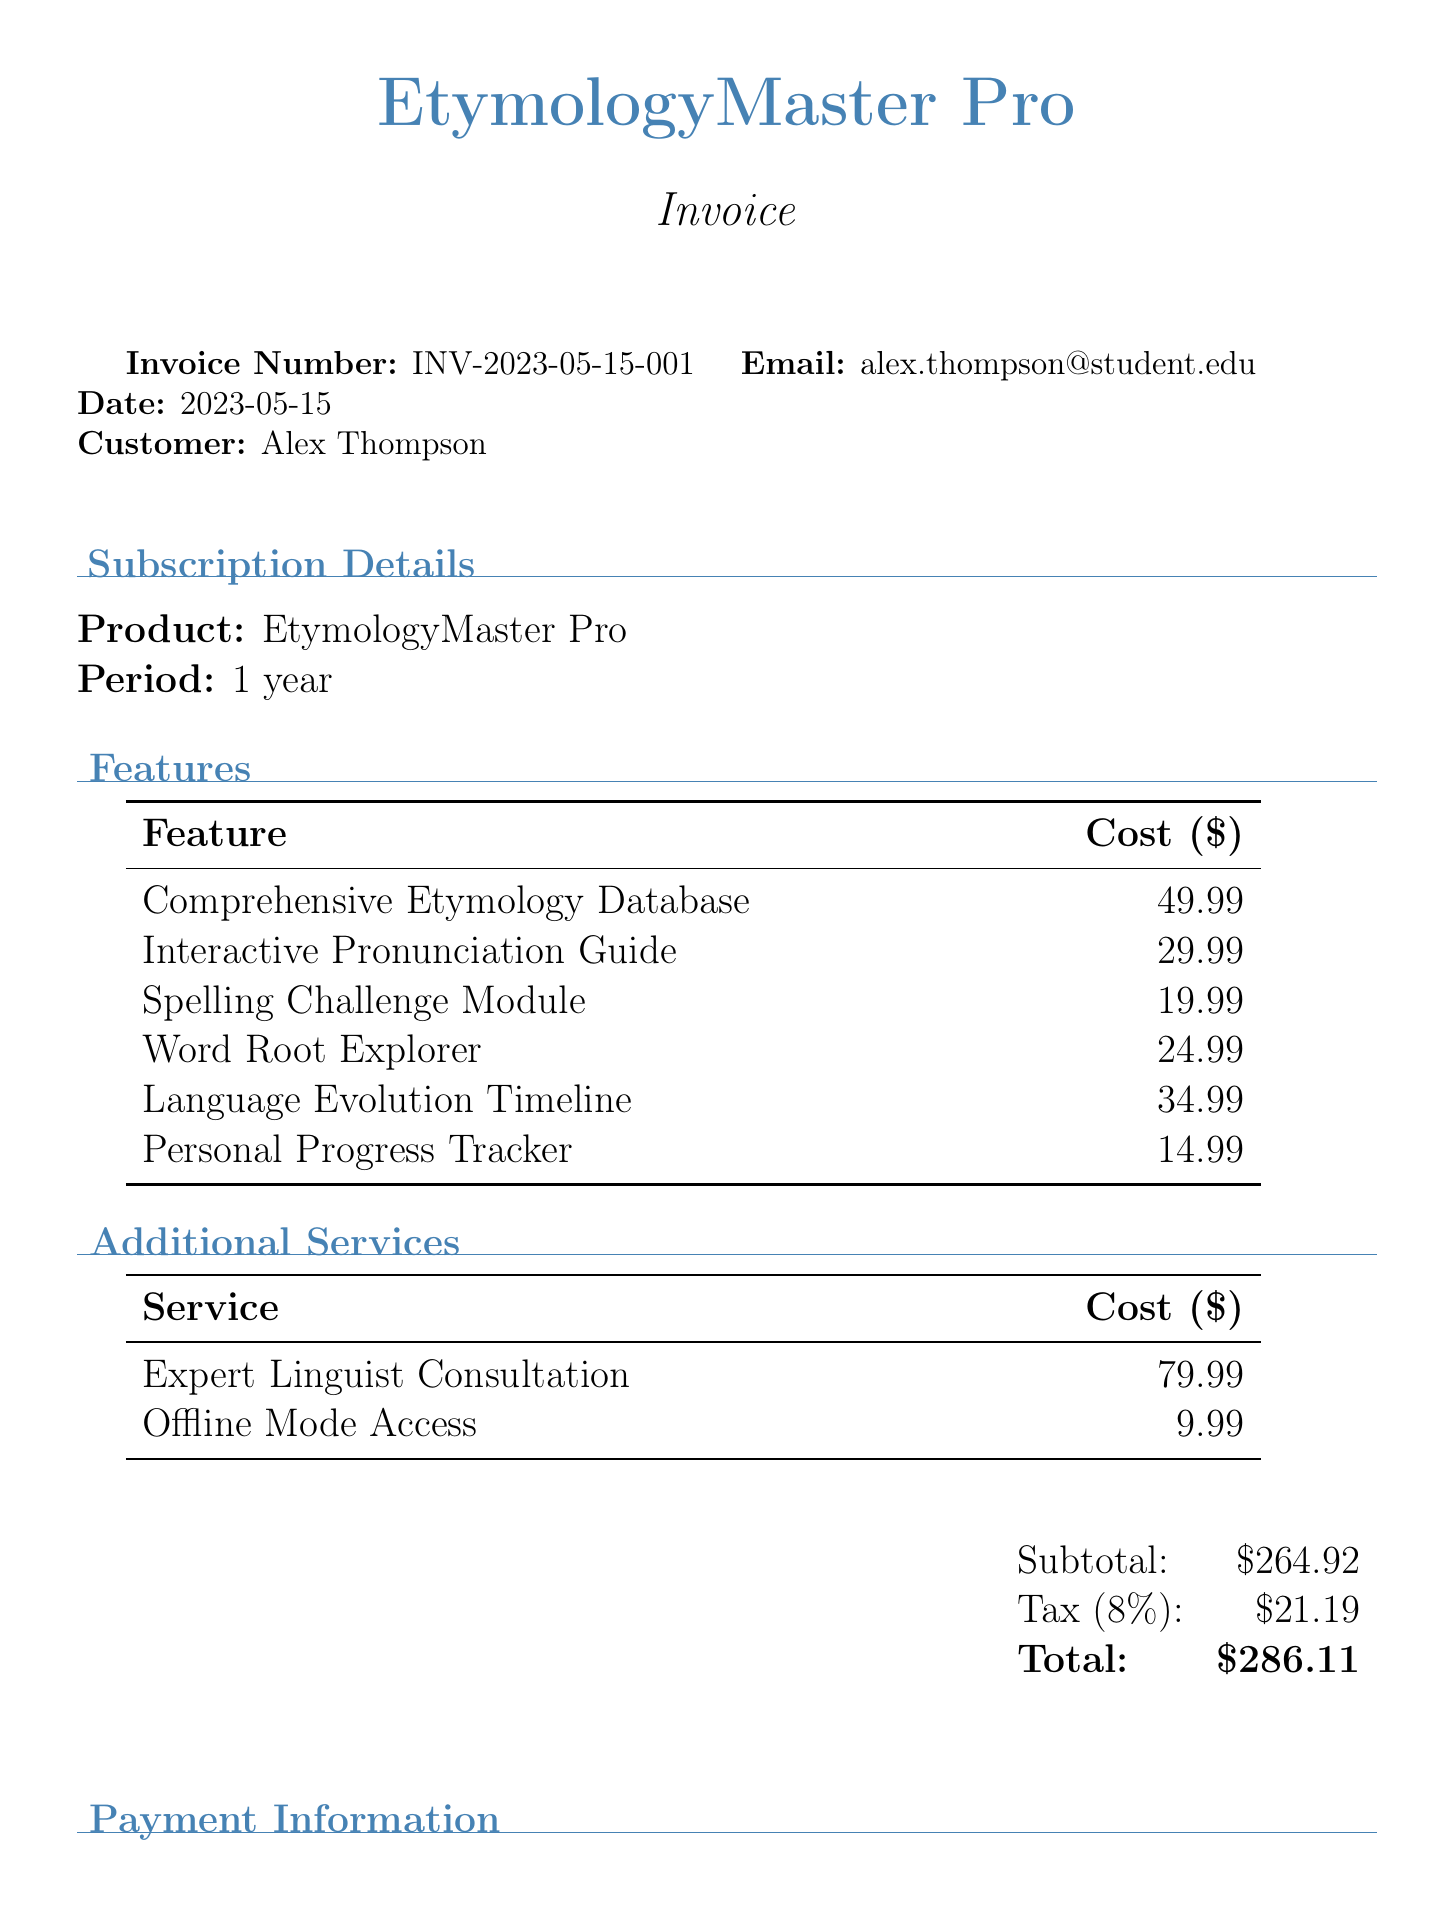What is the invoice number? The invoice number is clearly listed at the top of the document.
Answer: INV-2023-05-15-001 What is the customer's name? The customer's name is specified in the invoice details section.
Answer: Alex Thompson How much does the Interactive Pronunciation Guide cost? The cost of the Interactive Pronunciation Guide is itemized in the features table.
Answer: 29.99 What is the total amount due? The total amount is calculated at the bottom of the invoice.
Answer: 286.11 How many features are included in the subscription? The features section lists the total number of items, which can be counted.
Answer: 6 What is the tax rate applied to the invoice? The tax rate is mentioned alongside the tax amount in the financial summary.
Answer: 8% What type of payment method was used? The payment method is specified in the payment information section.
Answer: Credit Card What additional service costs the most? The additional services section lists services and their costs, allowing for comparison.
Answer: Expert Linguist Consultation What is the subscription period for EtymologyMaster Pro? The subscription period is stated in the subscription details section.
Answer: 1 year 